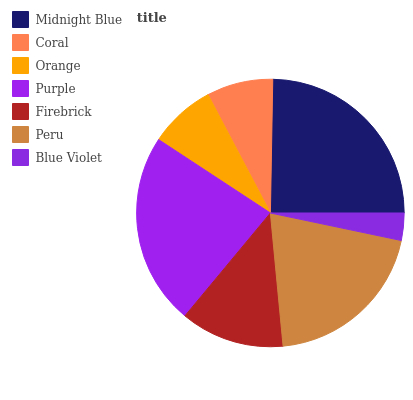Is Blue Violet the minimum?
Answer yes or no. Yes. Is Midnight Blue the maximum?
Answer yes or no. Yes. Is Coral the minimum?
Answer yes or no. No. Is Coral the maximum?
Answer yes or no. No. Is Midnight Blue greater than Coral?
Answer yes or no. Yes. Is Coral less than Midnight Blue?
Answer yes or no. Yes. Is Coral greater than Midnight Blue?
Answer yes or no. No. Is Midnight Blue less than Coral?
Answer yes or no. No. Is Firebrick the high median?
Answer yes or no. Yes. Is Firebrick the low median?
Answer yes or no. Yes. Is Orange the high median?
Answer yes or no. No. Is Peru the low median?
Answer yes or no. No. 